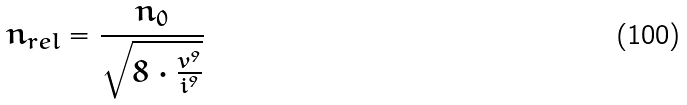Convert formula to latex. <formula><loc_0><loc_0><loc_500><loc_500>n _ { r e l } = \frac { n _ { 0 } } { \sqrt { 8 \cdot \frac { v ^ { 9 } } { i ^ { 9 } } } }</formula> 